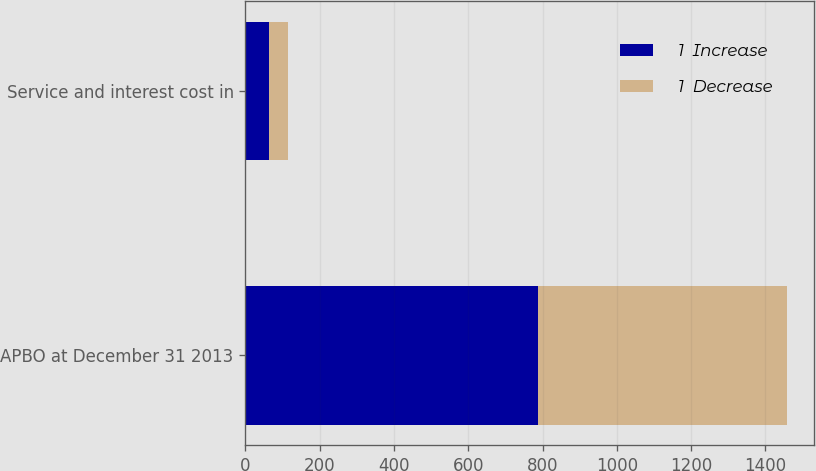Convert chart to OTSL. <chart><loc_0><loc_0><loc_500><loc_500><stacked_bar_chart><ecel><fcel>APBO at December 31 2013<fcel>Service and interest cost in<nl><fcel>1  Increase<fcel>788<fcel>63<nl><fcel>1  Decrease<fcel>671<fcel>52<nl></chart> 